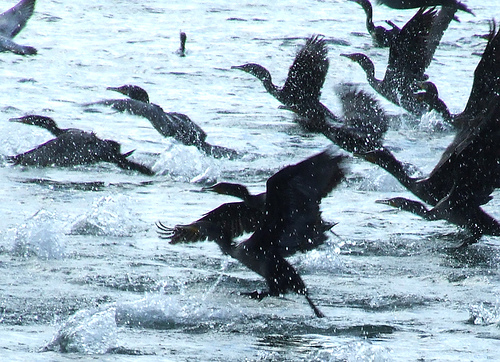Please provide the bounding box coordinate of the region this sentence describes: bird ascending into air. The bounding box coordinates for the region describing 'bird ascending into the air' are [0.18, 0.27, 0.47, 0.48]. This area highlights the moment of the bird taking flight. 